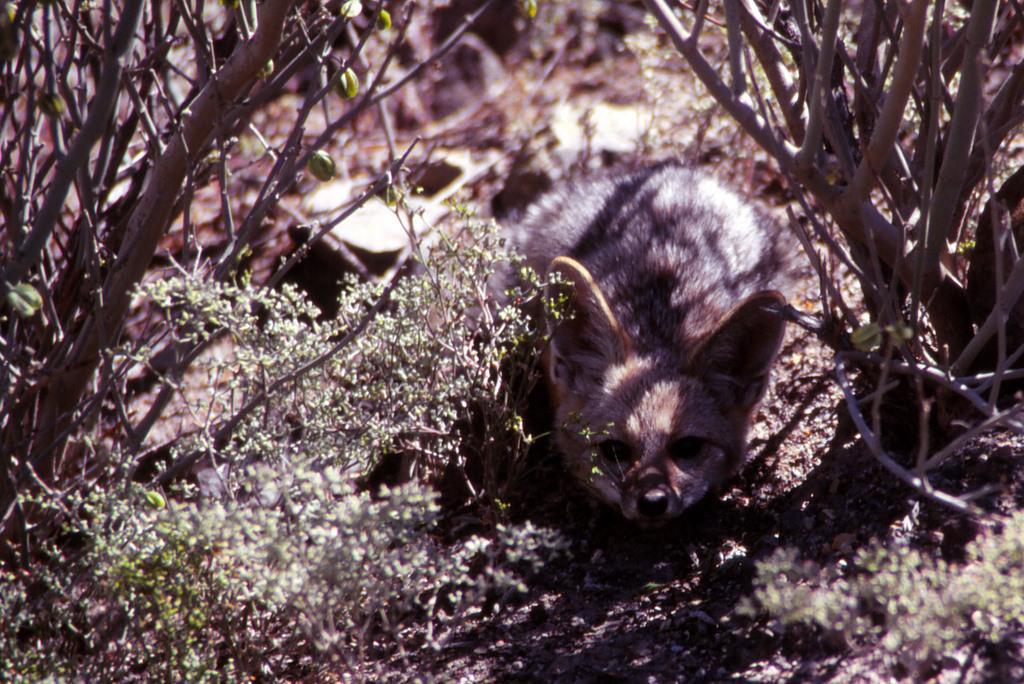What type of living organism can be seen in the image? There is an animal in the image. What other elements are present in the image besides the animal? There are plants in the image. Can you describe the background of the image? The background of the image is blurred. How many cobwebs can be seen in the image? There are no cobwebs present in the image. What is the acoustics like in the image? The provided facts do not give any information about the acoustics in the image. 